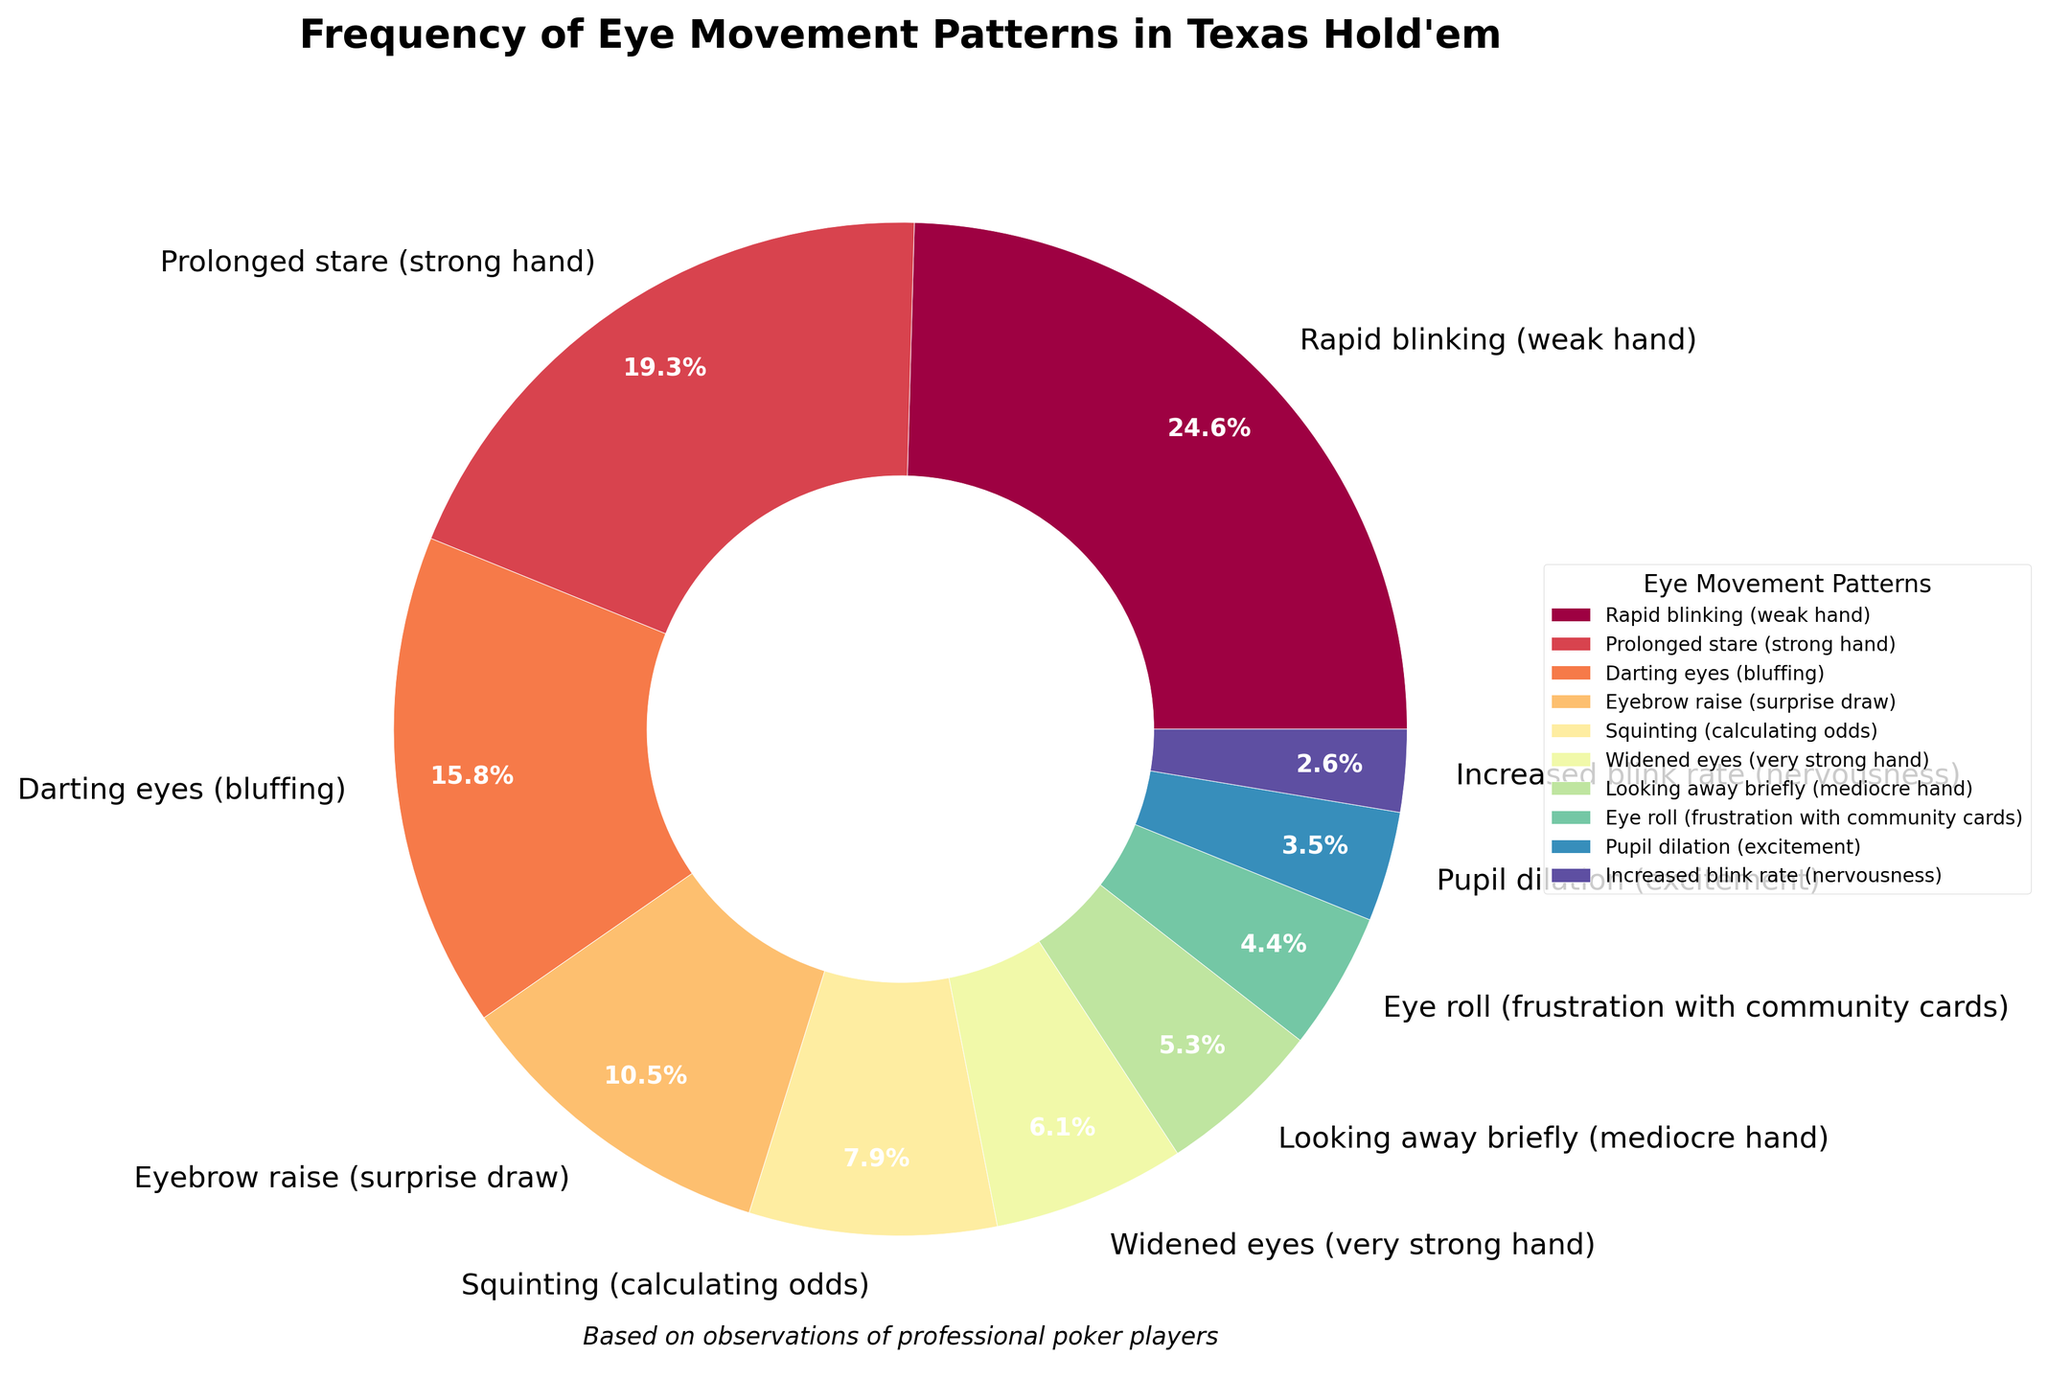Which eye movement pattern is most frequent? To determine the most frequent eye movement pattern, identify the largest slice in the pie chart and note its label.
Answer: Rapid blinking (weak hand) What is the combined frequency percentage of ‘Pupil dilation’ and ‘Increased blink rate'? Find the slices for 'Pupil dilation' (4%) and 'Increased blink rate' (3%) in the pie chart and add their percentages. 4% + 3% = 7%.
Answer: 7% How does the frequency of 'Prolonged stare' compare to 'Darting eyes'? Locate the slices for 'Prolonged stare' and 'Darting eyes' in the pie chart. Compare their percentages visually or by referring to the legend. 'Prolonged stare' is 22% and 'Darting eyes' is 18%, so 'Prolonged stare' is higher.
Answer: Prolonged stare is higher Which eye movement pattern associated with hand strength has the least frequency, and what is the percentage? Identify the smallest slice in the pie chart and note its label and percentage.
Answer: Increased blink rate (3%) What is the total frequency percentage for patterns indicative of very strong hands and excitement (‘Widened eyes’ and ‘Pupil dilation’)? Find and add the percentages of 'Widened eyes' (7%) and 'Pupil dilation' (4%). 7% + 4% = 11%.
Answer: 11% Which two patterns combined make up the largest frequency percentage, and what is the combined percentage? Identify the top two largest slices in the pie chart ('Rapid blinking' and 'Prolonged stare') and add their percentages. 28% + 22% = 50%.
Answer: Rapid blinking and Prolonged stare with 50% What percentage of the eye movement patterns corresponds to calculation or mediation (‘Squinting’ and ‘Looking away briefly’)? Add the percentages of 'Squinting' (9%) and 'Looking away briefly' (6%). 9% + 6% = 15%.
Answer: 15% Does the frequency of 'Eyebrow raise' indicate it is more common than 'Squinting'? Compare the size of the pie chart slices or percentages for 'Eyebrow raise' (12%) and 'Squinting' (9%). 'Eyebrow raise' is more frequent.
Answer: Yes 